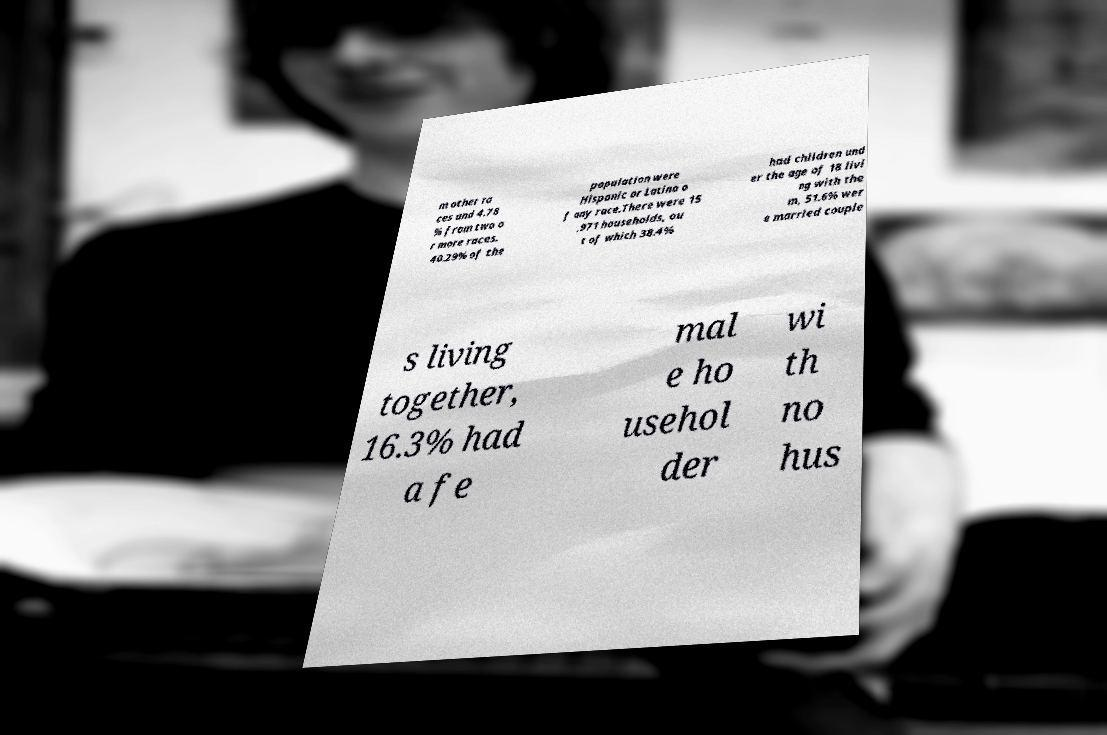Could you assist in decoding the text presented in this image and type it out clearly? m other ra ces and 4.78 % from two o r more races. 40.29% of the population were Hispanic or Latino o f any race.There were 15 ,971 households, ou t of which 38.4% had children und er the age of 18 livi ng with the m, 51.6% wer e married couple s living together, 16.3% had a fe mal e ho usehol der wi th no hus 